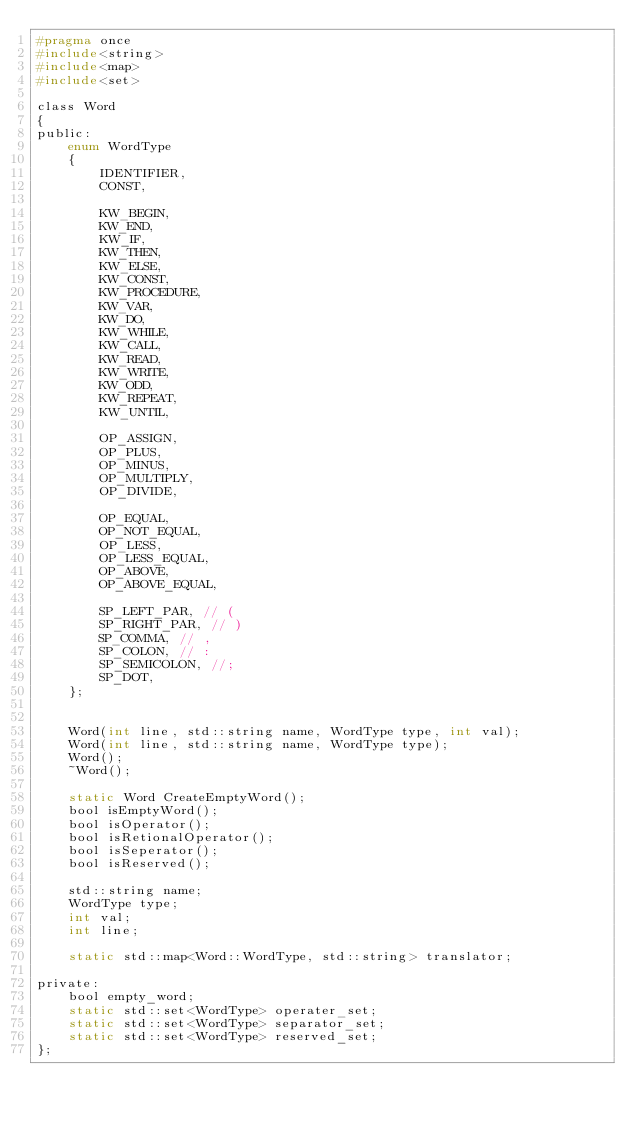Convert code to text. <code><loc_0><loc_0><loc_500><loc_500><_C_>#pragma once
#include<string>
#include<map>
#include<set>

class Word
{
public:
	enum WordType
	{
		IDENTIFIER,
		CONST,

		KW_BEGIN,
		KW_END,
		KW_IF,
		KW_THEN,
		KW_ELSE,
		KW_CONST,
		KW_PROCEDURE,
		KW_VAR,
		KW_DO,
		KW_WHILE,
		KW_CALL,
		KW_READ,
		KW_WRITE,
		KW_ODD,
		KW_REPEAT,
		KW_UNTIL,

		OP_ASSIGN,
		OP_PLUS,
		OP_MINUS,
		OP_MULTIPLY,
		OP_DIVIDE,

		OP_EQUAL,
		OP_NOT_EQUAL,
		OP_LESS,
		OP_LESS_EQUAL,
		OP_ABOVE,
		OP_ABOVE_EQUAL,

		SP_LEFT_PAR, // (
		SP_RIGHT_PAR, // )
		SP_COMMA, // ,
		SP_COLON, // :
		SP_SEMICOLON, //;
		SP_DOT,
	};


	Word(int line, std::string name, WordType type, int val);
	Word(int line, std::string name, WordType type);
	Word();
	~Word();

	static Word CreateEmptyWord();
	bool isEmptyWord();
	bool isOperator();
	bool isRetionalOperator();
	bool isSeperator();
	bool isReserved();

	std::string name;
	WordType type;
	int val;
	int line;

	static std::map<Word::WordType, std::string> translator;

private:
	bool empty_word;
	static std::set<WordType> operater_set;
	static std::set<WordType> separator_set;
	static std::set<WordType> reserved_set;
};

</code> 